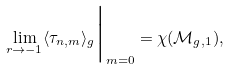Convert formula to latex. <formula><loc_0><loc_0><loc_500><loc_500>\lim _ { r \rightarrow - 1 } \langle \tau _ { n , m } \rangle _ { g } \Big | _ { m = 0 } = \chi ( \mathcal { M } _ { g , 1 } ) ,</formula> 